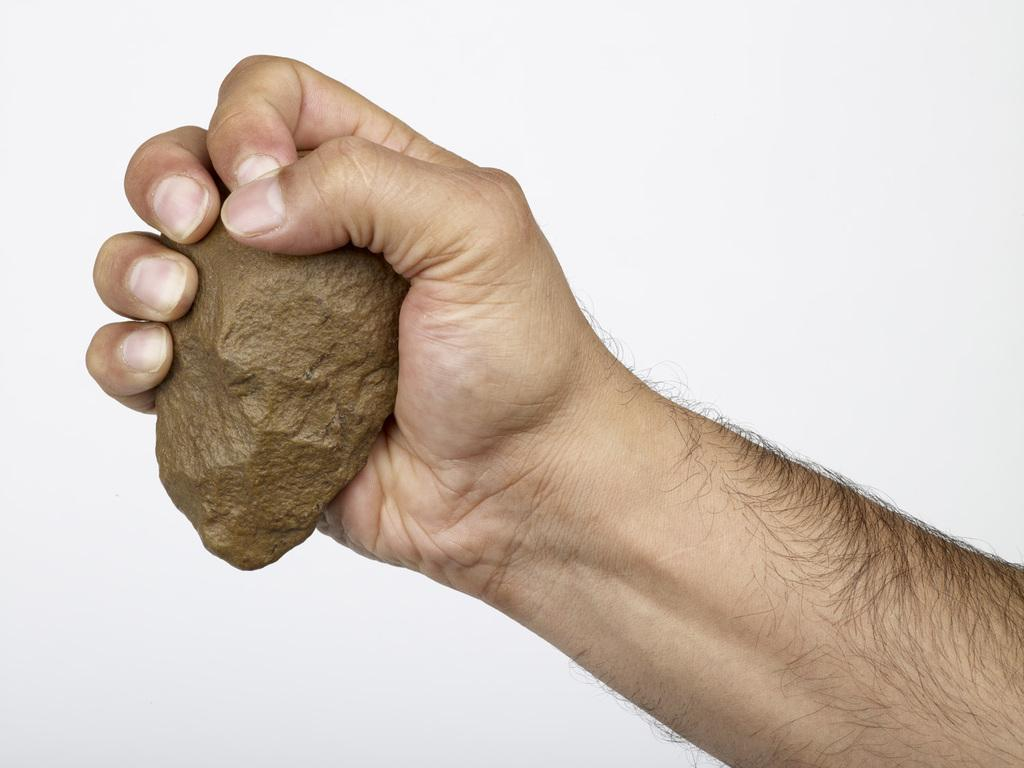What is the person's hand holding in the image? The person's hand is holding an object in the image. What can be observed about the background of the image? The background of the image is white. What type of bubble is being discussed in the group meeting in the image? There is no group meeting or bubble present in the image. 